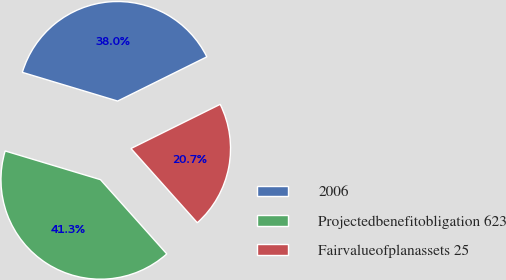<chart> <loc_0><loc_0><loc_500><loc_500><pie_chart><fcel>2006<fcel>Projectedbenefitobligation 623<fcel>Fairvalueofplanassets 25<nl><fcel>38.02%<fcel>41.26%<fcel>20.72%<nl></chart> 